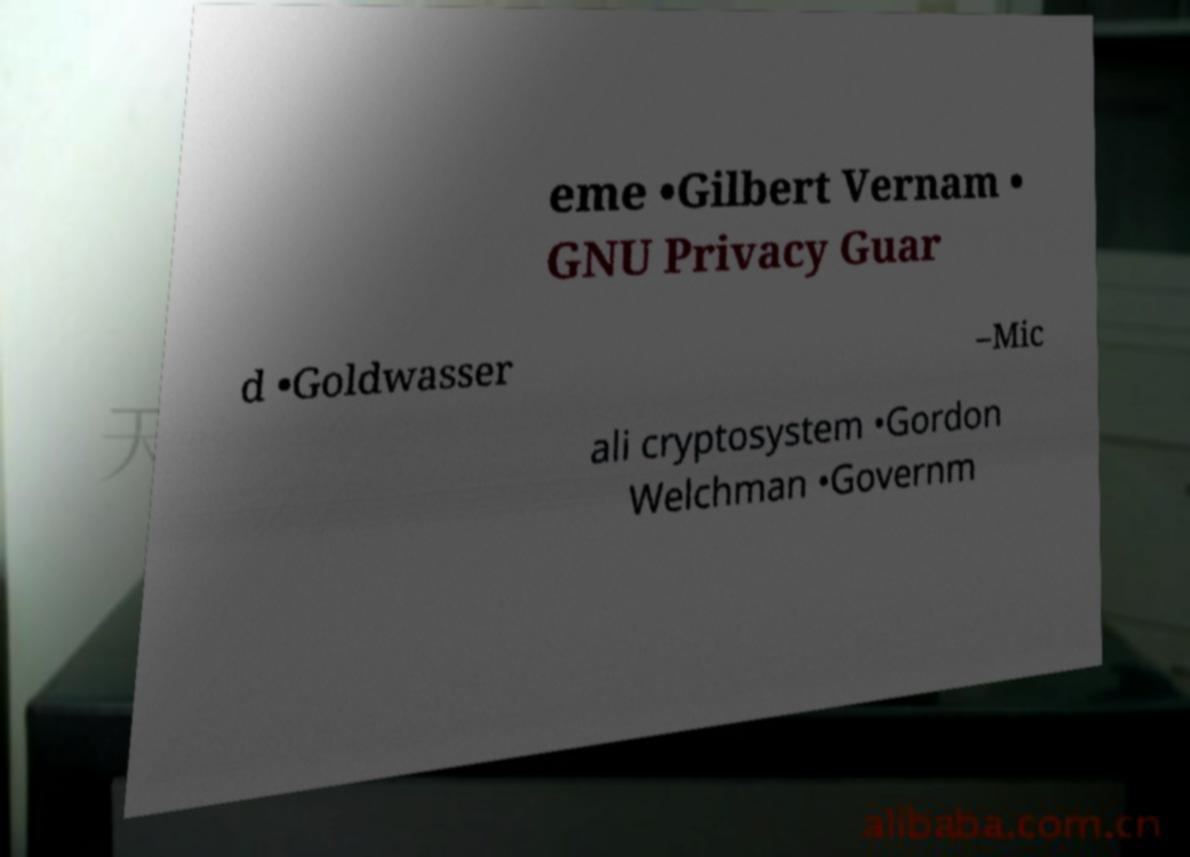What messages or text are displayed in this image? I need them in a readable, typed format. eme •Gilbert Vernam • GNU Privacy Guar d •Goldwasser –Mic ali cryptosystem •Gordon Welchman •Governm 